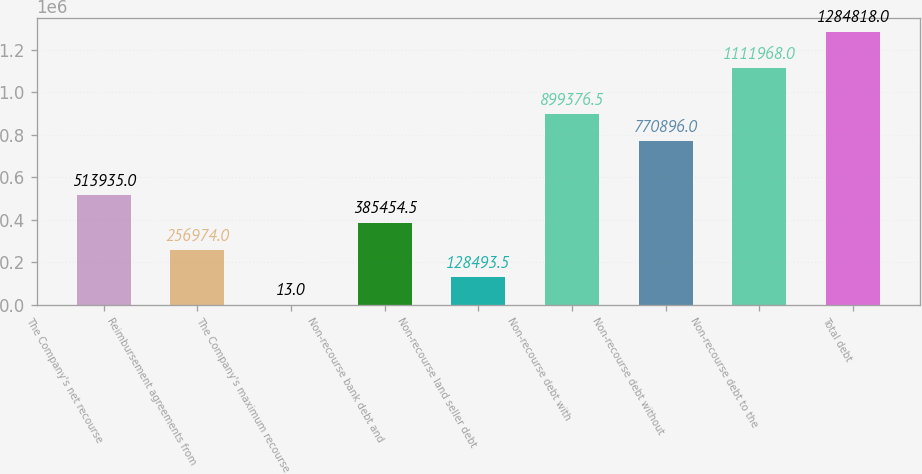<chart> <loc_0><loc_0><loc_500><loc_500><bar_chart><fcel>The Company's net recourse<fcel>Reimbursement agreements from<fcel>The Company's maximum recourse<fcel>Non-recourse bank debt and<fcel>Non-recourse land seller debt<fcel>Non-recourse debt with<fcel>Non-recourse debt without<fcel>Non-recourse debt to the<fcel>Total debt<nl><fcel>513935<fcel>256974<fcel>13<fcel>385454<fcel>128494<fcel>899376<fcel>770896<fcel>1.11197e+06<fcel>1.28482e+06<nl></chart> 